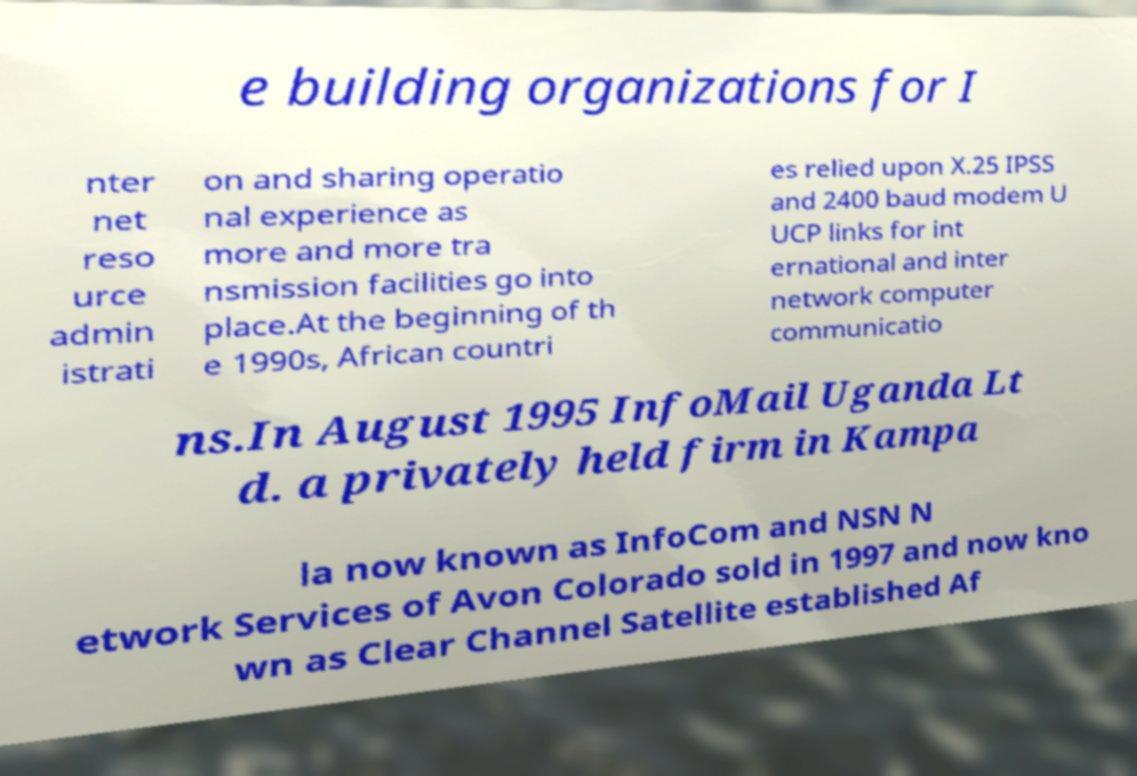For documentation purposes, I need the text within this image transcribed. Could you provide that? e building organizations for I nter net reso urce admin istrati on and sharing operatio nal experience as more and more tra nsmission facilities go into place.At the beginning of th e 1990s, African countri es relied upon X.25 IPSS and 2400 baud modem U UCP links for int ernational and inter network computer communicatio ns.In August 1995 InfoMail Uganda Lt d. a privately held firm in Kampa la now known as InfoCom and NSN N etwork Services of Avon Colorado sold in 1997 and now kno wn as Clear Channel Satellite established Af 